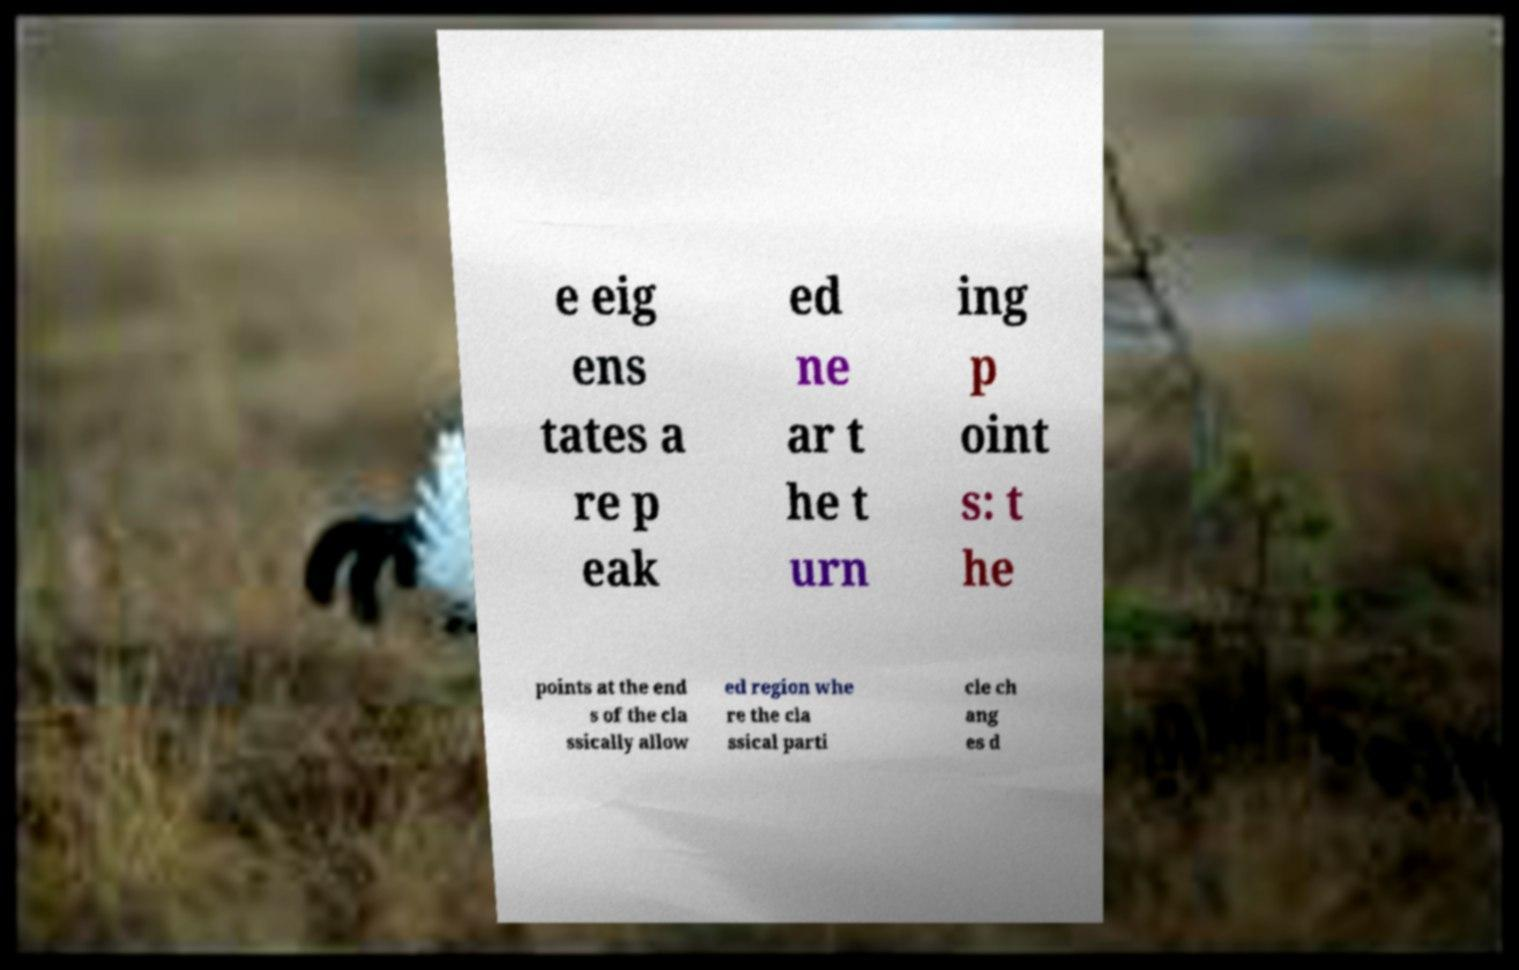Please read and relay the text visible in this image. What does it say? e eig ens tates a re p eak ed ne ar t he t urn ing p oint s: t he points at the end s of the cla ssically allow ed region whe re the cla ssical parti cle ch ang es d 